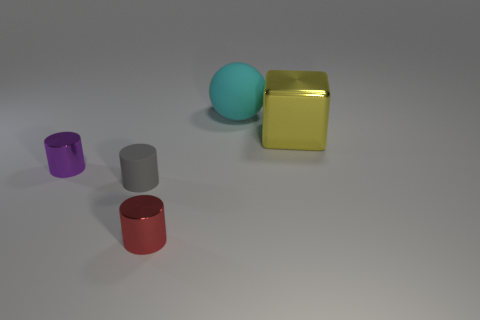Add 1 matte cylinders. How many objects exist? 6 Subtract all balls. How many objects are left? 4 Add 1 purple things. How many purple things exist? 2 Subtract 0 green cubes. How many objects are left? 5 Subtract all big brown matte spheres. Subtract all red shiny cylinders. How many objects are left? 4 Add 5 big matte spheres. How many big matte spheres are left? 6 